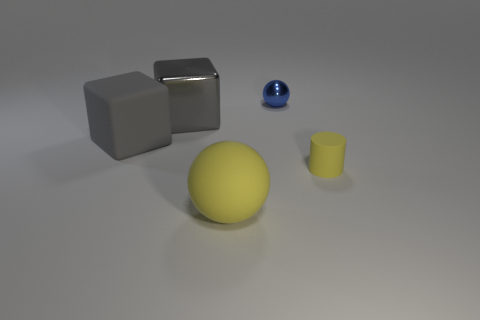There is another block that is the same color as the big rubber block; what size is it?
Offer a very short reply. Large. Is the thing in front of the yellow cylinder made of the same material as the gray block that is left of the big gray shiny block?
Offer a terse response. Yes. What material is the small thing that is behind the shiny thing that is in front of the tiny metal ball?
Your response must be concise. Metal. There is a yellow matte object that is to the right of the small object behind the metallic thing that is left of the small blue metal ball; what size is it?
Your answer should be compact. Small. Do the rubber ball and the gray rubber cube have the same size?
Provide a succinct answer. Yes. Does the matte thing right of the large sphere have the same shape as the big rubber object to the right of the gray metal cube?
Offer a very short reply. No. There is a big matte object behind the big yellow matte object; is there a big yellow matte ball that is on the left side of it?
Offer a terse response. No. Is there a tiny brown metal cylinder?
Offer a very short reply. No. What number of other balls are the same size as the yellow matte ball?
Provide a succinct answer. 0. What number of things are behind the small rubber cylinder and left of the tiny shiny thing?
Provide a short and direct response. 2. 